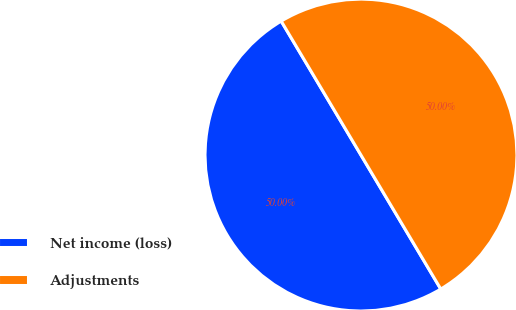Convert chart to OTSL. <chart><loc_0><loc_0><loc_500><loc_500><pie_chart><fcel>Net income (loss)<fcel>Adjustments<nl><fcel>50.0%<fcel>50.0%<nl></chart> 